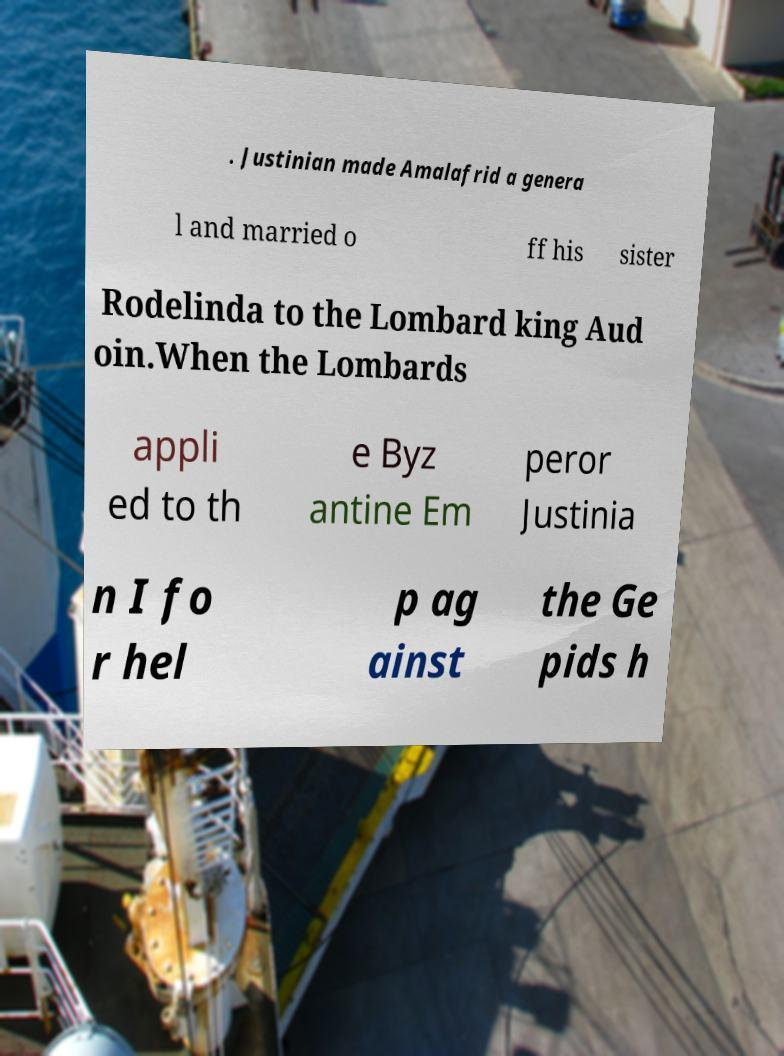Can you accurately transcribe the text from the provided image for me? . Justinian made Amalafrid a genera l and married o ff his sister Rodelinda to the Lombard king Aud oin.When the Lombards appli ed to th e Byz antine Em peror Justinia n I fo r hel p ag ainst the Ge pids h 